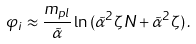<formula> <loc_0><loc_0><loc_500><loc_500>\varphi _ { i } \approx \frac { m _ { p l } } { \tilde { \alpha } } \ln { ( \tilde { \alpha } ^ { 2 } \zeta N + \tilde { \alpha } ^ { 2 } \zeta ) } \, .</formula> 